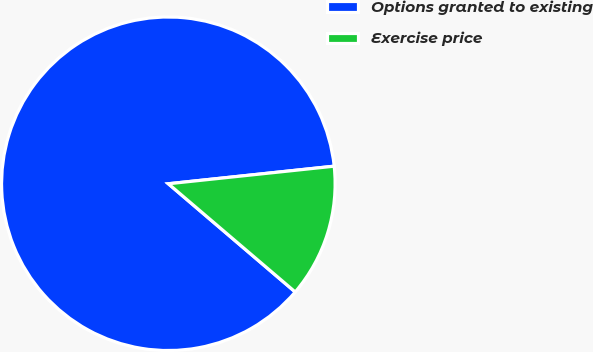Convert chart to OTSL. <chart><loc_0><loc_0><loc_500><loc_500><pie_chart><fcel>Options granted to existing<fcel>Exercise price<nl><fcel>87.08%<fcel>12.92%<nl></chart> 